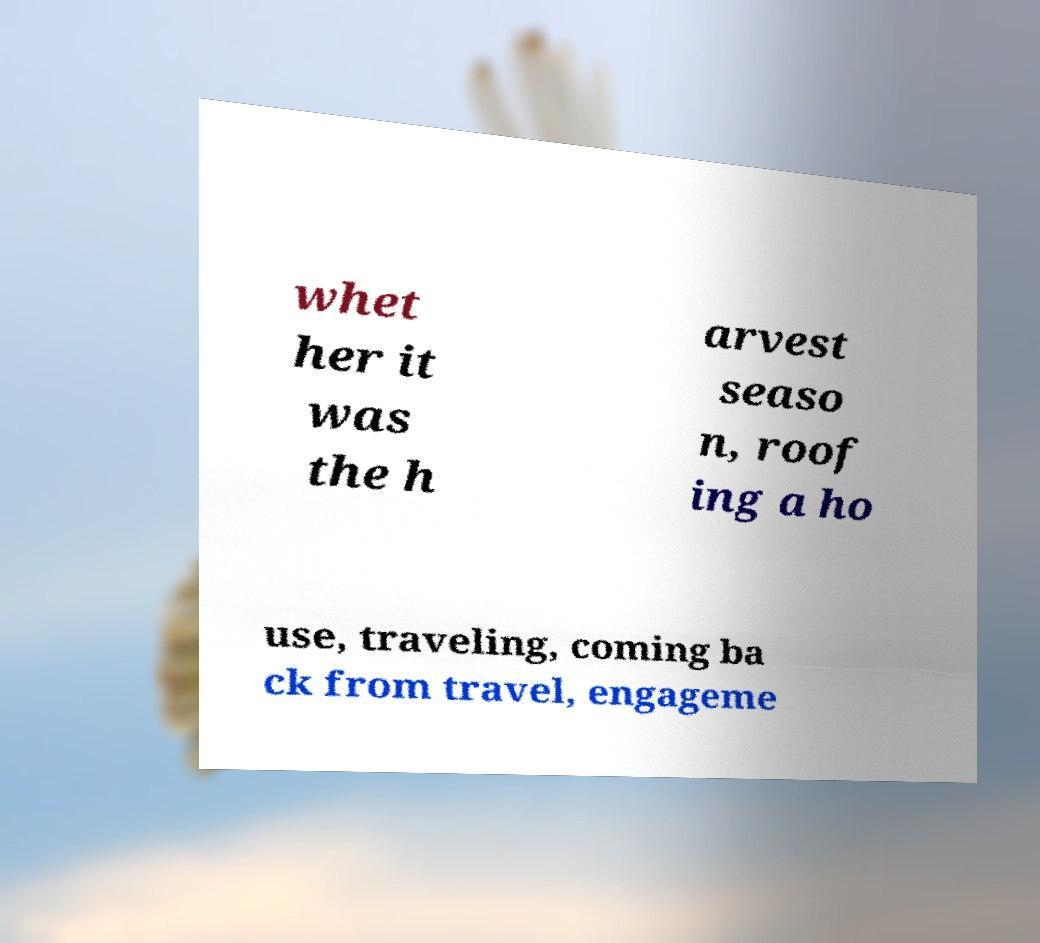There's text embedded in this image that I need extracted. Can you transcribe it verbatim? whet her it was the h arvest seaso n, roof ing a ho use, traveling, coming ba ck from travel, engageme 